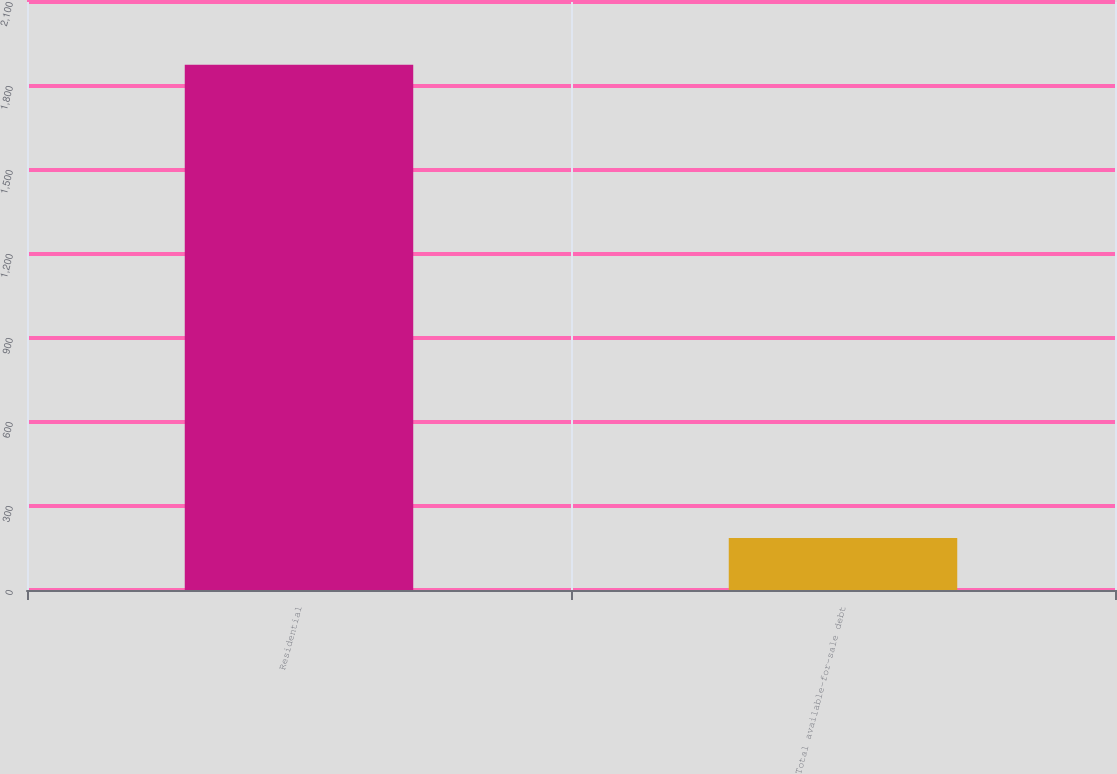Convert chart. <chart><loc_0><loc_0><loc_500><loc_500><bar_chart><fcel>Residential<fcel>Total available-for-sale debt<nl><fcel>1876<fcel>186<nl></chart> 